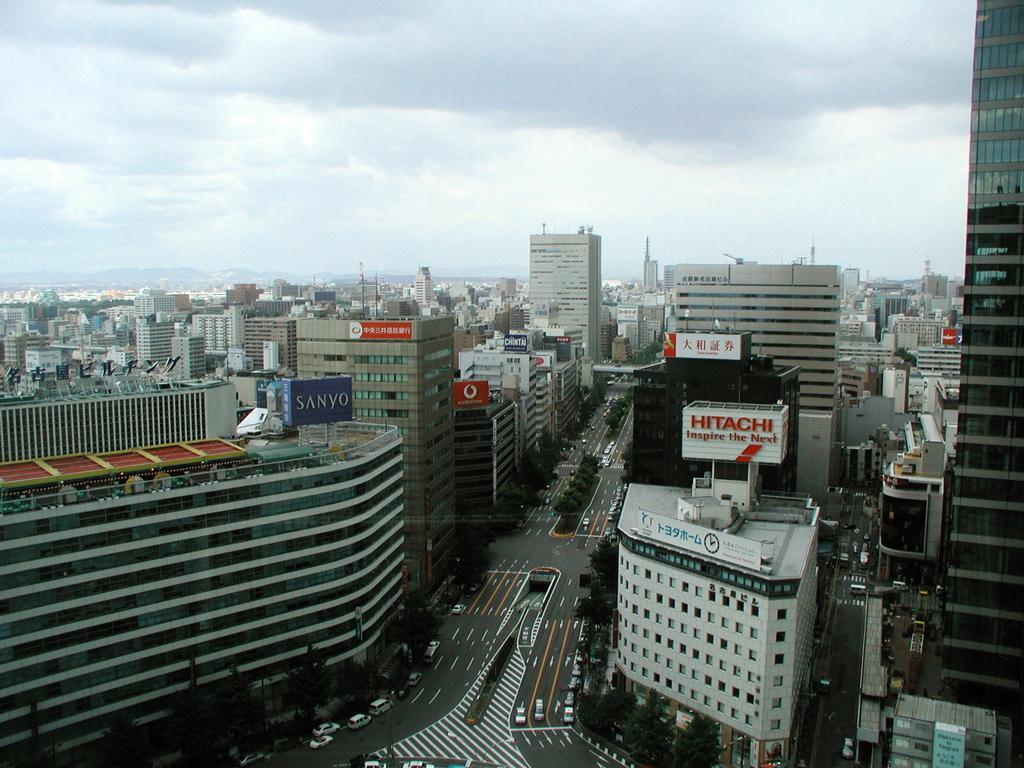Can you describe this image briefly? In the center of the image there are buildings. There is a road on which there are cars. At the top of the image there is sky. 